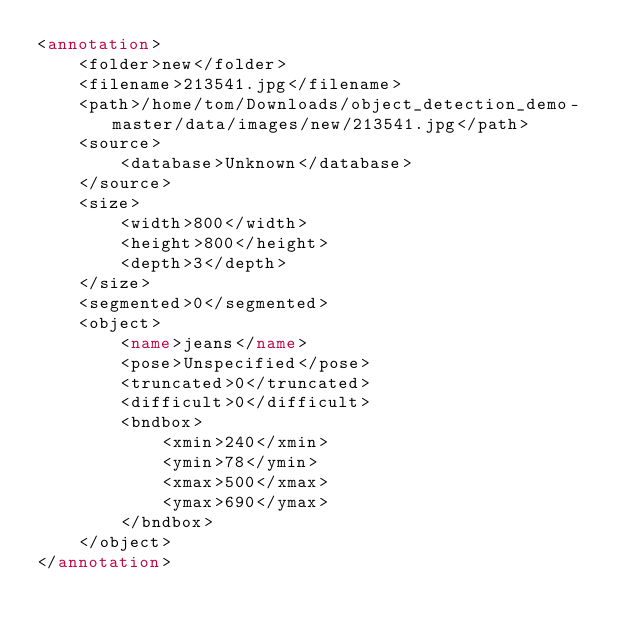<code> <loc_0><loc_0><loc_500><loc_500><_XML_><annotation>
	<folder>new</folder>
	<filename>213541.jpg</filename>
	<path>/home/tom/Downloads/object_detection_demo-master/data/images/new/213541.jpg</path>
	<source>
		<database>Unknown</database>
	</source>
	<size>
		<width>800</width>
		<height>800</height>
		<depth>3</depth>
	</size>
	<segmented>0</segmented>
	<object>
		<name>jeans</name>
		<pose>Unspecified</pose>
		<truncated>0</truncated>
		<difficult>0</difficult>
		<bndbox>
			<xmin>240</xmin>
			<ymin>78</ymin>
			<xmax>500</xmax>
			<ymax>690</ymax>
		</bndbox>
	</object>
</annotation>
</code> 